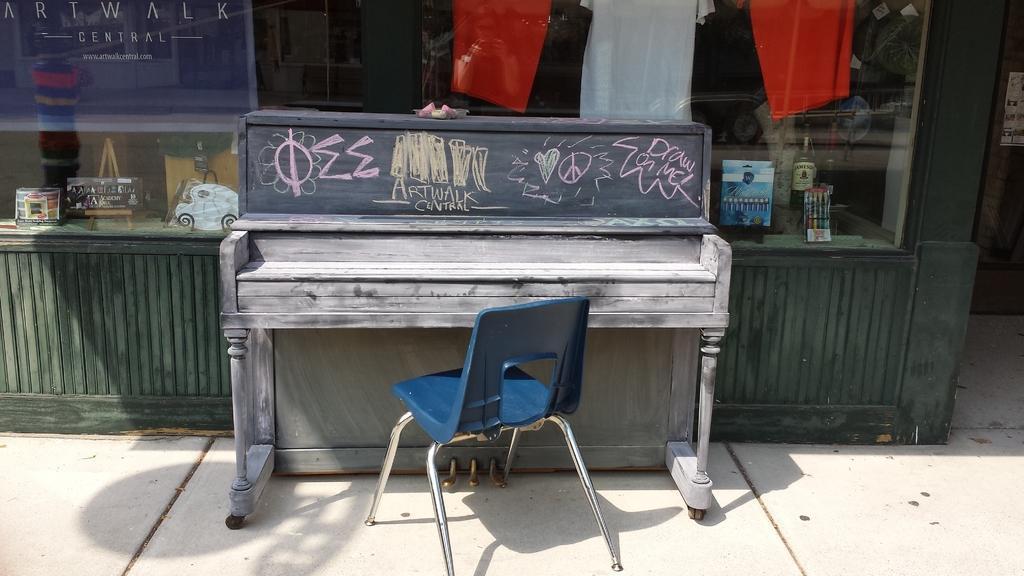Can you describe this image briefly? As we can see in the image there is a building, cloths, table and chair. 